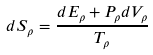Convert formula to latex. <formula><loc_0><loc_0><loc_500><loc_500>d S _ { \rho } = \frac { d E _ { \rho } + P _ { \rho } d V _ { \rho } } { T _ { \rho } }</formula> 